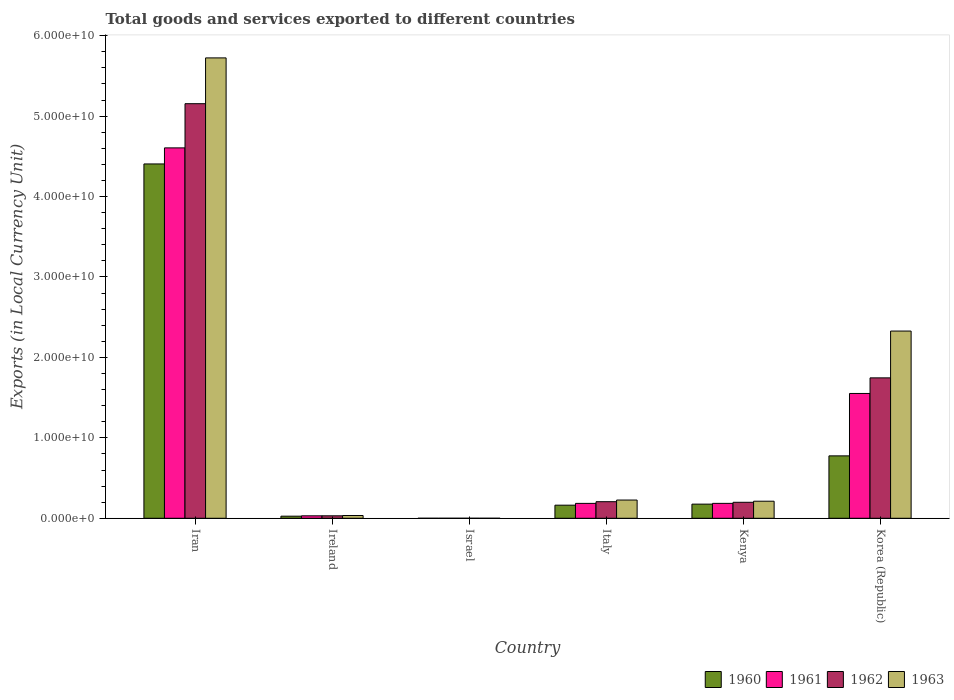How many different coloured bars are there?
Give a very brief answer. 4. Are the number of bars per tick equal to the number of legend labels?
Give a very brief answer. Yes. Are the number of bars on each tick of the X-axis equal?
Make the answer very short. Yes. How many bars are there on the 1st tick from the left?
Give a very brief answer. 4. How many bars are there on the 2nd tick from the right?
Give a very brief answer. 4. What is the label of the 4th group of bars from the left?
Ensure brevity in your answer.  Italy. What is the Amount of goods and services exports in 1961 in Iran?
Ensure brevity in your answer.  4.60e+1. Across all countries, what is the maximum Amount of goods and services exports in 1961?
Your answer should be compact. 4.60e+1. Across all countries, what is the minimum Amount of goods and services exports in 1961?
Your response must be concise. 7.24e+04. In which country was the Amount of goods and services exports in 1962 maximum?
Offer a terse response. Iran. What is the total Amount of goods and services exports in 1960 in the graph?
Ensure brevity in your answer.  5.55e+1. What is the difference between the Amount of goods and services exports in 1962 in Ireland and that in Kenya?
Ensure brevity in your answer.  -1.68e+09. What is the difference between the Amount of goods and services exports in 1960 in Iran and the Amount of goods and services exports in 1962 in Italy?
Keep it short and to the point. 4.20e+1. What is the average Amount of goods and services exports in 1960 per country?
Offer a very short reply. 9.24e+09. What is the difference between the Amount of goods and services exports of/in 1960 and Amount of goods and services exports of/in 1963 in Israel?
Your answer should be very brief. -1.06e+05. In how many countries, is the Amount of goods and services exports in 1960 greater than 38000000000 LCU?
Give a very brief answer. 1. What is the ratio of the Amount of goods and services exports in 1963 in Ireland to that in Kenya?
Your response must be concise. 0.16. What is the difference between the highest and the second highest Amount of goods and services exports in 1962?
Provide a short and direct response. 3.41e+1. What is the difference between the highest and the lowest Amount of goods and services exports in 1962?
Provide a short and direct response. 5.15e+1. In how many countries, is the Amount of goods and services exports in 1961 greater than the average Amount of goods and services exports in 1961 taken over all countries?
Provide a succinct answer. 2. Is the sum of the Amount of goods and services exports in 1961 in Iran and Ireland greater than the maximum Amount of goods and services exports in 1963 across all countries?
Offer a terse response. No. What does the 3rd bar from the right in Italy represents?
Provide a short and direct response. 1961. How many bars are there?
Your answer should be very brief. 24. Are all the bars in the graph horizontal?
Your response must be concise. No. How many countries are there in the graph?
Provide a short and direct response. 6. What is the difference between two consecutive major ticks on the Y-axis?
Offer a very short reply. 1.00e+1. How are the legend labels stacked?
Make the answer very short. Horizontal. What is the title of the graph?
Keep it short and to the point. Total goods and services exported to different countries. Does "1981" appear as one of the legend labels in the graph?
Offer a terse response. No. What is the label or title of the X-axis?
Provide a succinct answer. Country. What is the label or title of the Y-axis?
Your response must be concise. Exports (in Local Currency Unit). What is the Exports (in Local Currency Unit) in 1960 in Iran?
Your answer should be very brief. 4.41e+1. What is the Exports (in Local Currency Unit) in 1961 in Iran?
Make the answer very short. 4.60e+1. What is the Exports (in Local Currency Unit) of 1962 in Iran?
Offer a terse response. 5.15e+1. What is the Exports (in Local Currency Unit) of 1963 in Iran?
Provide a succinct answer. 5.72e+1. What is the Exports (in Local Currency Unit) of 1960 in Ireland?
Offer a very short reply. 2.60e+08. What is the Exports (in Local Currency Unit) of 1961 in Ireland?
Keep it short and to the point. 3.04e+08. What is the Exports (in Local Currency Unit) in 1962 in Ireland?
Offer a very short reply. 3.07e+08. What is the Exports (in Local Currency Unit) of 1963 in Ireland?
Offer a very short reply. 3.43e+08. What is the Exports (in Local Currency Unit) in 1960 in Israel?
Your answer should be very brief. 6.19e+04. What is the Exports (in Local Currency Unit) in 1961 in Israel?
Provide a short and direct response. 7.24e+04. What is the Exports (in Local Currency Unit) in 1962 in Israel?
Give a very brief answer. 1.34e+05. What is the Exports (in Local Currency Unit) in 1963 in Israel?
Ensure brevity in your answer.  1.67e+05. What is the Exports (in Local Currency Unit) of 1960 in Italy?
Keep it short and to the point. 1.63e+09. What is the Exports (in Local Currency Unit) in 1961 in Italy?
Provide a short and direct response. 1.85e+09. What is the Exports (in Local Currency Unit) in 1962 in Italy?
Your answer should be very brief. 2.06e+09. What is the Exports (in Local Currency Unit) in 1963 in Italy?
Ensure brevity in your answer.  2.27e+09. What is the Exports (in Local Currency Unit) in 1960 in Kenya?
Your response must be concise. 1.76e+09. What is the Exports (in Local Currency Unit) in 1961 in Kenya?
Keep it short and to the point. 1.85e+09. What is the Exports (in Local Currency Unit) in 1962 in Kenya?
Offer a terse response. 1.99e+09. What is the Exports (in Local Currency Unit) of 1963 in Kenya?
Give a very brief answer. 2.12e+09. What is the Exports (in Local Currency Unit) of 1960 in Korea (Republic)?
Provide a succinct answer. 7.76e+09. What is the Exports (in Local Currency Unit) of 1961 in Korea (Republic)?
Ensure brevity in your answer.  1.55e+1. What is the Exports (in Local Currency Unit) in 1962 in Korea (Republic)?
Make the answer very short. 1.75e+1. What is the Exports (in Local Currency Unit) of 1963 in Korea (Republic)?
Your response must be concise. 2.33e+1. Across all countries, what is the maximum Exports (in Local Currency Unit) in 1960?
Give a very brief answer. 4.41e+1. Across all countries, what is the maximum Exports (in Local Currency Unit) in 1961?
Your answer should be very brief. 4.60e+1. Across all countries, what is the maximum Exports (in Local Currency Unit) of 1962?
Keep it short and to the point. 5.15e+1. Across all countries, what is the maximum Exports (in Local Currency Unit) of 1963?
Offer a terse response. 5.72e+1. Across all countries, what is the minimum Exports (in Local Currency Unit) in 1960?
Keep it short and to the point. 6.19e+04. Across all countries, what is the minimum Exports (in Local Currency Unit) in 1961?
Ensure brevity in your answer.  7.24e+04. Across all countries, what is the minimum Exports (in Local Currency Unit) of 1962?
Your response must be concise. 1.34e+05. Across all countries, what is the minimum Exports (in Local Currency Unit) in 1963?
Ensure brevity in your answer.  1.67e+05. What is the total Exports (in Local Currency Unit) of 1960 in the graph?
Ensure brevity in your answer.  5.55e+1. What is the total Exports (in Local Currency Unit) in 1961 in the graph?
Ensure brevity in your answer.  6.56e+1. What is the total Exports (in Local Currency Unit) in 1962 in the graph?
Your answer should be compact. 7.34e+1. What is the total Exports (in Local Currency Unit) in 1963 in the graph?
Your answer should be compact. 8.52e+1. What is the difference between the Exports (in Local Currency Unit) in 1960 in Iran and that in Ireland?
Keep it short and to the point. 4.38e+1. What is the difference between the Exports (in Local Currency Unit) in 1961 in Iran and that in Ireland?
Your answer should be very brief. 4.57e+1. What is the difference between the Exports (in Local Currency Unit) in 1962 in Iran and that in Ireland?
Ensure brevity in your answer.  5.12e+1. What is the difference between the Exports (in Local Currency Unit) in 1963 in Iran and that in Ireland?
Your answer should be very brief. 5.69e+1. What is the difference between the Exports (in Local Currency Unit) of 1960 in Iran and that in Israel?
Offer a terse response. 4.41e+1. What is the difference between the Exports (in Local Currency Unit) of 1961 in Iran and that in Israel?
Provide a short and direct response. 4.60e+1. What is the difference between the Exports (in Local Currency Unit) in 1962 in Iran and that in Israel?
Provide a succinct answer. 5.15e+1. What is the difference between the Exports (in Local Currency Unit) in 1963 in Iran and that in Israel?
Keep it short and to the point. 5.72e+1. What is the difference between the Exports (in Local Currency Unit) of 1960 in Iran and that in Italy?
Your answer should be very brief. 4.24e+1. What is the difference between the Exports (in Local Currency Unit) of 1961 in Iran and that in Italy?
Offer a terse response. 4.42e+1. What is the difference between the Exports (in Local Currency Unit) in 1962 in Iran and that in Italy?
Provide a succinct answer. 4.95e+1. What is the difference between the Exports (in Local Currency Unit) of 1963 in Iran and that in Italy?
Your answer should be compact. 5.50e+1. What is the difference between the Exports (in Local Currency Unit) of 1960 in Iran and that in Kenya?
Make the answer very short. 4.23e+1. What is the difference between the Exports (in Local Currency Unit) of 1961 in Iran and that in Kenya?
Provide a short and direct response. 4.42e+1. What is the difference between the Exports (in Local Currency Unit) of 1962 in Iran and that in Kenya?
Offer a terse response. 4.96e+1. What is the difference between the Exports (in Local Currency Unit) in 1963 in Iran and that in Kenya?
Offer a very short reply. 5.51e+1. What is the difference between the Exports (in Local Currency Unit) in 1960 in Iran and that in Korea (Republic)?
Ensure brevity in your answer.  3.63e+1. What is the difference between the Exports (in Local Currency Unit) in 1961 in Iran and that in Korea (Republic)?
Offer a terse response. 3.05e+1. What is the difference between the Exports (in Local Currency Unit) of 1962 in Iran and that in Korea (Republic)?
Your answer should be compact. 3.41e+1. What is the difference between the Exports (in Local Currency Unit) of 1963 in Iran and that in Korea (Republic)?
Offer a terse response. 3.40e+1. What is the difference between the Exports (in Local Currency Unit) in 1960 in Ireland and that in Israel?
Ensure brevity in your answer.  2.60e+08. What is the difference between the Exports (in Local Currency Unit) of 1961 in Ireland and that in Israel?
Your answer should be compact. 3.04e+08. What is the difference between the Exports (in Local Currency Unit) of 1962 in Ireland and that in Israel?
Your answer should be very brief. 3.06e+08. What is the difference between the Exports (in Local Currency Unit) of 1963 in Ireland and that in Israel?
Keep it short and to the point. 3.43e+08. What is the difference between the Exports (in Local Currency Unit) of 1960 in Ireland and that in Italy?
Offer a terse response. -1.37e+09. What is the difference between the Exports (in Local Currency Unit) of 1961 in Ireland and that in Italy?
Provide a succinct answer. -1.55e+09. What is the difference between the Exports (in Local Currency Unit) in 1962 in Ireland and that in Italy?
Make the answer very short. -1.75e+09. What is the difference between the Exports (in Local Currency Unit) in 1963 in Ireland and that in Italy?
Ensure brevity in your answer.  -1.92e+09. What is the difference between the Exports (in Local Currency Unit) of 1960 in Ireland and that in Kenya?
Keep it short and to the point. -1.50e+09. What is the difference between the Exports (in Local Currency Unit) in 1961 in Ireland and that in Kenya?
Make the answer very short. -1.55e+09. What is the difference between the Exports (in Local Currency Unit) in 1962 in Ireland and that in Kenya?
Keep it short and to the point. -1.68e+09. What is the difference between the Exports (in Local Currency Unit) in 1963 in Ireland and that in Kenya?
Make the answer very short. -1.78e+09. What is the difference between the Exports (in Local Currency Unit) in 1960 in Ireland and that in Korea (Republic)?
Your answer should be compact. -7.50e+09. What is the difference between the Exports (in Local Currency Unit) of 1961 in Ireland and that in Korea (Republic)?
Your answer should be compact. -1.52e+1. What is the difference between the Exports (in Local Currency Unit) in 1962 in Ireland and that in Korea (Republic)?
Your answer should be very brief. -1.72e+1. What is the difference between the Exports (in Local Currency Unit) of 1963 in Ireland and that in Korea (Republic)?
Your answer should be very brief. -2.29e+1. What is the difference between the Exports (in Local Currency Unit) of 1960 in Israel and that in Italy?
Offer a terse response. -1.63e+09. What is the difference between the Exports (in Local Currency Unit) in 1961 in Israel and that in Italy?
Keep it short and to the point. -1.85e+09. What is the difference between the Exports (in Local Currency Unit) in 1962 in Israel and that in Italy?
Keep it short and to the point. -2.06e+09. What is the difference between the Exports (in Local Currency Unit) of 1963 in Israel and that in Italy?
Your answer should be compact. -2.27e+09. What is the difference between the Exports (in Local Currency Unit) in 1960 in Israel and that in Kenya?
Your answer should be compact. -1.76e+09. What is the difference between the Exports (in Local Currency Unit) in 1961 in Israel and that in Kenya?
Offer a very short reply. -1.85e+09. What is the difference between the Exports (in Local Currency Unit) of 1962 in Israel and that in Kenya?
Provide a short and direct response. -1.99e+09. What is the difference between the Exports (in Local Currency Unit) of 1963 in Israel and that in Kenya?
Your response must be concise. -2.12e+09. What is the difference between the Exports (in Local Currency Unit) in 1960 in Israel and that in Korea (Republic)?
Offer a terse response. -7.76e+09. What is the difference between the Exports (in Local Currency Unit) in 1961 in Israel and that in Korea (Republic)?
Provide a short and direct response. -1.55e+1. What is the difference between the Exports (in Local Currency Unit) of 1962 in Israel and that in Korea (Republic)?
Provide a succinct answer. -1.75e+1. What is the difference between the Exports (in Local Currency Unit) of 1963 in Israel and that in Korea (Republic)?
Your answer should be very brief. -2.33e+1. What is the difference between the Exports (in Local Currency Unit) in 1960 in Italy and that in Kenya?
Your response must be concise. -1.31e+08. What is the difference between the Exports (in Local Currency Unit) in 1961 in Italy and that in Kenya?
Offer a terse response. -1.45e+06. What is the difference between the Exports (in Local Currency Unit) of 1962 in Italy and that in Kenya?
Offer a terse response. 7.40e+07. What is the difference between the Exports (in Local Currency Unit) of 1963 in Italy and that in Kenya?
Offer a terse response. 1.46e+08. What is the difference between the Exports (in Local Currency Unit) in 1960 in Italy and that in Korea (Republic)?
Your answer should be compact. -6.13e+09. What is the difference between the Exports (in Local Currency Unit) of 1961 in Italy and that in Korea (Republic)?
Ensure brevity in your answer.  -1.37e+1. What is the difference between the Exports (in Local Currency Unit) of 1962 in Italy and that in Korea (Republic)?
Provide a succinct answer. -1.54e+1. What is the difference between the Exports (in Local Currency Unit) of 1963 in Italy and that in Korea (Republic)?
Provide a succinct answer. -2.10e+1. What is the difference between the Exports (in Local Currency Unit) of 1960 in Kenya and that in Korea (Republic)?
Provide a succinct answer. -6.00e+09. What is the difference between the Exports (in Local Currency Unit) of 1961 in Kenya and that in Korea (Republic)?
Your response must be concise. -1.37e+1. What is the difference between the Exports (in Local Currency Unit) in 1962 in Kenya and that in Korea (Republic)?
Offer a terse response. -1.55e+1. What is the difference between the Exports (in Local Currency Unit) in 1963 in Kenya and that in Korea (Republic)?
Give a very brief answer. -2.12e+1. What is the difference between the Exports (in Local Currency Unit) in 1960 in Iran and the Exports (in Local Currency Unit) in 1961 in Ireland?
Provide a succinct answer. 4.37e+1. What is the difference between the Exports (in Local Currency Unit) in 1960 in Iran and the Exports (in Local Currency Unit) in 1962 in Ireland?
Your response must be concise. 4.37e+1. What is the difference between the Exports (in Local Currency Unit) of 1960 in Iran and the Exports (in Local Currency Unit) of 1963 in Ireland?
Give a very brief answer. 4.37e+1. What is the difference between the Exports (in Local Currency Unit) of 1961 in Iran and the Exports (in Local Currency Unit) of 1962 in Ireland?
Make the answer very short. 4.57e+1. What is the difference between the Exports (in Local Currency Unit) in 1961 in Iran and the Exports (in Local Currency Unit) in 1963 in Ireland?
Offer a very short reply. 4.57e+1. What is the difference between the Exports (in Local Currency Unit) of 1962 in Iran and the Exports (in Local Currency Unit) of 1963 in Ireland?
Ensure brevity in your answer.  5.12e+1. What is the difference between the Exports (in Local Currency Unit) in 1960 in Iran and the Exports (in Local Currency Unit) in 1961 in Israel?
Your response must be concise. 4.41e+1. What is the difference between the Exports (in Local Currency Unit) of 1960 in Iran and the Exports (in Local Currency Unit) of 1962 in Israel?
Offer a very short reply. 4.41e+1. What is the difference between the Exports (in Local Currency Unit) of 1960 in Iran and the Exports (in Local Currency Unit) of 1963 in Israel?
Make the answer very short. 4.41e+1. What is the difference between the Exports (in Local Currency Unit) of 1961 in Iran and the Exports (in Local Currency Unit) of 1962 in Israel?
Your response must be concise. 4.60e+1. What is the difference between the Exports (in Local Currency Unit) of 1961 in Iran and the Exports (in Local Currency Unit) of 1963 in Israel?
Offer a terse response. 4.60e+1. What is the difference between the Exports (in Local Currency Unit) of 1962 in Iran and the Exports (in Local Currency Unit) of 1963 in Israel?
Provide a succinct answer. 5.15e+1. What is the difference between the Exports (in Local Currency Unit) in 1960 in Iran and the Exports (in Local Currency Unit) in 1961 in Italy?
Offer a terse response. 4.22e+1. What is the difference between the Exports (in Local Currency Unit) of 1960 in Iran and the Exports (in Local Currency Unit) of 1962 in Italy?
Provide a succinct answer. 4.20e+1. What is the difference between the Exports (in Local Currency Unit) of 1960 in Iran and the Exports (in Local Currency Unit) of 1963 in Italy?
Provide a succinct answer. 4.18e+1. What is the difference between the Exports (in Local Currency Unit) of 1961 in Iran and the Exports (in Local Currency Unit) of 1962 in Italy?
Provide a short and direct response. 4.40e+1. What is the difference between the Exports (in Local Currency Unit) in 1961 in Iran and the Exports (in Local Currency Unit) in 1963 in Italy?
Offer a very short reply. 4.38e+1. What is the difference between the Exports (in Local Currency Unit) in 1962 in Iran and the Exports (in Local Currency Unit) in 1963 in Italy?
Your answer should be very brief. 4.93e+1. What is the difference between the Exports (in Local Currency Unit) in 1960 in Iran and the Exports (in Local Currency Unit) in 1961 in Kenya?
Make the answer very short. 4.22e+1. What is the difference between the Exports (in Local Currency Unit) of 1960 in Iran and the Exports (in Local Currency Unit) of 1962 in Kenya?
Your answer should be very brief. 4.21e+1. What is the difference between the Exports (in Local Currency Unit) in 1960 in Iran and the Exports (in Local Currency Unit) in 1963 in Kenya?
Your response must be concise. 4.19e+1. What is the difference between the Exports (in Local Currency Unit) in 1961 in Iran and the Exports (in Local Currency Unit) in 1962 in Kenya?
Ensure brevity in your answer.  4.41e+1. What is the difference between the Exports (in Local Currency Unit) of 1961 in Iran and the Exports (in Local Currency Unit) of 1963 in Kenya?
Offer a terse response. 4.39e+1. What is the difference between the Exports (in Local Currency Unit) in 1962 in Iran and the Exports (in Local Currency Unit) in 1963 in Kenya?
Ensure brevity in your answer.  4.94e+1. What is the difference between the Exports (in Local Currency Unit) in 1960 in Iran and the Exports (in Local Currency Unit) in 1961 in Korea (Republic)?
Ensure brevity in your answer.  2.85e+1. What is the difference between the Exports (in Local Currency Unit) in 1960 in Iran and the Exports (in Local Currency Unit) in 1962 in Korea (Republic)?
Your response must be concise. 2.66e+1. What is the difference between the Exports (in Local Currency Unit) of 1960 in Iran and the Exports (in Local Currency Unit) of 1963 in Korea (Republic)?
Your response must be concise. 2.08e+1. What is the difference between the Exports (in Local Currency Unit) of 1961 in Iran and the Exports (in Local Currency Unit) of 1962 in Korea (Republic)?
Provide a succinct answer. 2.86e+1. What is the difference between the Exports (in Local Currency Unit) in 1961 in Iran and the Exports (in Local Currency Unit) in 1963 in Korea (Republic)?
Your answer should be compact. 2.28e+1. What is the difference between the Exports (in Local Currency Unit) of 1962 in Iran and the Exports (in Local Currency Unit) of 1963 in Korea (Republic)?
Make the answer very short. 2.83e+1. What is the difference between the Exports (in Local Currency Unit) of 1960 in Ireland and the Exports (in Local Currency Unit) of 1961 in Israel?
Provide a short and direct response. 2.60e+08. What is the difference between the Exports (in Local Currency Unit) in 1960 in Ireland and the Exports (in Local Currency Unit) in 1962 in Israel?
Your response must be concise. 2.60e+08. What is the difference between the Exports (in Local Currency Unit) of 1960 in Ireland and the Exports (in Local Currency Unit) of 1963 in Israel?
Your response must be concise. 2.60e+08. What is the difference between the Exports (in Local Currency Unit) in 1961 in Ireland and the Exports (in Local Currency Unit) in 1962 in Israel?
Your answer should be compact. 3.04e+08. What is the difference between the Exports (in Local Currency Unit) in 1961 in Ireland and the Exports (in Local Currency Unit) in 1963 in Israel?
Make the answer very short. 3.04e+08. What is the difference between the Exports (in Local Currency Unit) in 1962 in Ireland and the Exports (in Local Currency Unit) in 1963 in Israel?
Keep it short and to the point. 3.06e+08. What is the difference between the Exports (in Local Currency Unit) of 1960 in Ireland and the Exports (in Local Currency Unit) of 1961 in Italy?
Provide a succinct answer. -1.59e+09. What is the difference between the Exports (in Local Currency Unit) of 1960 in Ireland and the Exports (in Local Currency Unit) of 1962 in Italy?
Offer a very short reply. -1.80e+09. What is the difference between the Exports (in Local Currency Unit) of 1960 in Ireland and the Exports (in Local Currency Unit) of 1963 in Italy?
Ensure brevity in your answer.  -2.01e+09. What is the difference between the Exports (in Local Currency Unit) in 1961 in Ireland and the Exports (in Local Currency Unit) in 1962 in Italy?
Keep it short and to the point. -1.76e+09. What is the difference between the Exports (in Local Currency Unit) of 1961 in Ireland and the Exports (in Local Currency Unit) of 1963 in Italy?
Give a very brief answer. -1.96e+09. What is the difference between the Exports (in Local Currency Unit) of 1962 in Ireland and the Exports (in Local Currency Unit) of 1963 in Italy?
Make the answer very short. -1.96e+09. What is the difference between the Exports (in Local Currency Unit) of 1960 in Ireland and the Exports (in Local Currency Unit) of 1961 in Kenya?
Provide a short and direct response. -1.59e+09. What is the difference between the Exports (in Local Currency Unit) in 1960 in Ireland and the Exports (in Local Currency Unit) in 1962 in Kenya?
Ensure brevity in your answer.  -1.73e+09. What is the difference between the Exports (in Local Currency Unit) of 1960 in Ireland and the Exports (in Local Currency Unit) of 1963 in Kenya?
Make the answer very short. -1.86e+09. What is the difference between the Exports (in Local Currency Unit) of 1961 in Ireland and the Exports (in Local Currency Unit) of 1962 in Kenya?
Your answer should be compact. -1.68e+09. What is the difference between the Exports (in Local Currency Unit) in 1961 in Ireland and the Exports (in Local Currency Unit) in 1963 in Kenya?
Keep it short and to the point. -1.82e+09. What is the difference between the Exports (in Local Currency Unit) of 1962 in Ireland and the Exports (in Local Currency Unit) of 1963 in Kenya?
Make the answer very short. -1.81e+09. What is the difference between the Exports (in Local Currency Unit) of 1960 in Ireland and the Exports (in Local Currency Unit) of 1961 in Korea (Republic)?
Your answer should be very brief. -1.53e+1. What is the difference between the Exports (in Local Currency Unit) in 1960 in Ireland and the Exports (in Local Currency Unit) in 1962 in Korea (Republic)?
Your answer should be very brief. -1.72e+1. What is the difference between the Exports (in Local Currency Unit) in 1960 in Ireland and the Exports (in Local Currency Unit) in 1963 in Korea (Republic)?
Offer a very short reply. -2.30e+1. What is the difference between the Exports (in Local Currency Unit) in 1961 in Ireland and the Exports (in Local Currency Unit) in 1962 in Korea (Republic)?
Offer a terse response. -1.72e+1. What is the difference between the Exports (in Local Currency Unit) in 1961 in Ireland and the Exports (in Local Currency Unit) in 1963 in Korea (Republic)?
Offer a very short reply. -2.30e+1. What is the difference between the Exports (in Local Currency Unit) of 1962 in Ireland and the Exports (in Local Currency Unit) of 1963 in Korea (Republic)?
Give a very brief answer. -2.30e+1. What is the difference between the Exports (in Local Currency Unit) of 1960 in Israel and the Exports (in Local Currency Unit) of 1961 in Italy?
Give a very brief answer. -1.85e+09. What is the difference between the Exports (in Local Currency Unit) in 1960 in Israel and the Exports (in Local Currency Unit) in 1962 in Italy?
Provide a short and direct response. -2.06e+09. What is the difference between the Exports (in Local Currency Unit) of 1960 in Israel and the Exports (in Local Currency Unit) of 1963 in Italy?
Offer a terse response. -2.27e+09. What is the difference between the Exports (in Local Currency Unit) of 1961 in Israel and the Exports (in Local Currency Unit) of 1962 in Italy?
Give a very brief answer. -2.06e+09. What is the difference between the Exports (in Local Currency Unit) of 1961 in Israel and the Exports (in Local Currency Unit) of 1963 in Italy?
Ensure brevity in your answer.  -2.27e+09. What is the difference between the Exports (in Local Currency Unit) in 1962 in Israel and the Exports (in Local Currency Unit) in 1963 in Italy?
Your response must be concise. -2.27e+09. What is the difference between the Exports (in Local Currency Unit) of 1960 in Israel and the Exports (in Local Currency Unit) of 1961 in Kenya?
Offer a terse response. -1.85e+09. What is the difference between the Exports (in Local Currency Unit) in 1960 in Israel and the Exports (in Local Currency Unit) in 1962 in Kenya?
Provide a short and direct response. -1.99e+09. What is the difference between the Exports (in Local Currency Unit) of 1960 in Israel and the Exports (in Local Currency Unit) of 1963 in Kenya?
Your response must be concise. -2.12e+09. What is the difference between the Exports (in Local Currency Unit) in 1961 in Israel and the Exports (in Local Currency Unit) in 1962 in Kenya?
Give a very brief answer. -1.99e+09. What is the difference between the Exports (in Local Currency Unit) in 1961 in Israel and the Exports (in Local Currency Unit) in 1963 in Kenya?
Your response must be concise. -2.12e+09. What is the difference between the Exports (in Local Currency Unit) in 1962 in Israel and the Exports (in Local Currency Unit) in 1963 in Kenya?
Your answer should be compact. -2.12e+09. What is the difference between the Exports (in Local Currency Unit) of 1960 in Israel and the Exports (in Local Currency Unit) of 1961 in Korea (Republic)?
Give a very brief answer. -1.55e+1. What is the difference between the Exports (in Local Currency Unit) of 1960 in Israel and the Exports (in Local Currency Unit) of 1962 in Korea (Republic)?
Ensure brevity in your answer.  -1.75e+1. What is the difference between the Exports (in Local Currency Unit) in 1960 in Israel and the Exports (in Local Currency Unit) in 1963 in Korea (Republic)?
Provide a short and direct response. -2.33e+1. What is the difference between the Exports (in Local Currency Unit) of 1961 in Israel and the Exports (in Local Currency Unit) of 1962 in Korea (Republic)?
Offer a very short reply. -1.75e+1. What is the difference between the Exports (in Local Currency Unit) of 1961 in Israel and the Exports (in Local Currency Unit) of 1963 in Korea (Republic)?
Provide a succinct answer. -2.33e+1. What is the difference between the Exports (in Local Currency Unit) of 1962 in Israel and the Exports (in Local Currency Unit) of 1963 in Korea (Republic)?
Your response must be concise. -2.33e+1. What is the difference between the Exports (in Local Currency Unit) of 1960 in Italy and the Exports (in Local Currency Unit) of 1961 in Kenya?
Your response must be concise. -2.27e+08. What is the difference between the Exports (in Local Currency Unit) in 1960 in Italy and the Exports (in Local Currency Unit) in 1962 in Kenya?
Provide a succinct answer. -3.60e+08. What is the difference between the Exports (in Local Currency Unit) of 1960 in Italy and the Exports (in Local Currency Unit) of 1963 in Kenya?
Your response must be concise. -4.94e+08. What is the difference between the Exports (in Local Currency Unit) of 1961 in Italy and the Exports (in Local Currency Unit) of 1962 in Kenya?
Keep it short and to the point. -1.35e+08. What is the difference between the Exports (in Local Currency Unit) in 1961 in Italy and the Exports (in Local Currency Unit) in 1963 in Kenya?
Your answer should be very brief. -2.68e+08. What is the difference between the Exports (in Local Currency Unit) in 1962 in Italy and the Exports (in Local Currency Unit) in 1963 in Kenya?
Ensure brevity in your answer.  -5.95e+07. What is the difference between the Exports (in Local Currency Unit) of 1960 in Italy and the Exports (in Local Currency Unit) of 1961 in Korea (Republic)?
Your response must be concise. -1.39e+1. What is the difference between the Exports (in Local Currency Unit) in 1960 in Italy and the Exports (in Local Currency Unit) in 1962 in Korea (Republic)?
Keep it short and to the point. -1.58e+1. What is the difference between the Exports (in Local Currency Unit) of 1960 in Italy and the Exports (in Local Currency Unit) of 1963 in Korea (Republic)?
Your answer should be very brief. -2.16e+1. What is the difference between the Exports (in Local Currency Unit) of 1961 in Italy and the Exports (in Local Currency Unit) of 1962 in Korea (Republic)?
Make the answer very short. -1.56e+1. What is the difference between the Exports (in Local Currency Unit) of 1961 in Italy and the Exports (in Local Currency Unit) of 1963 in Korea (Republic)?
Give a very brief answer. -2.14e+1. What is the difference between the Exports (in Local Currency Unit) of 1962 in Italy and the Exports (in Local Currency Unit) of 1963 in Korea (Republic)?
Offer a very short reply. -2.12e+1. What is the difference between the Exports (in Local Currency Unit) of 1960 in Kenya and the Exports (in Local Currency Unit) of 1961 in Korea (Republic)?
Your response must be concise. -1.38e+1. What is the difference between the Exports (in Local Currency Unit) of 1960 in Kenya and the Exports (in Local Currency Unit) of 1962 in Korea (Republic)?
Provide a succinct answer. -1.57e+1. What is the difference between the Exports (in Local Currency Unit) of 1960 in Kenya and the Exports (in Local Currency Unit) of 1963 in Korea (Republic)?
Give a very brief answer. -2.15e+1. What is the difference between the Exports (in Local Currency Unit) of 1961 in Kenya and the Exports (in Local Currency Unit) of 1962 in Korea (Republic)?
Your answer should be compact. -1.56e+1. What is the difference between the Exports (in Local Currency Unit) of 1961 in Kenya and the Exports (in Local Currency Unit) of 1963 in Korea (Republic)?
Offer a terse response. -2.14e+1. What is the difference between the Exports (in Local Currency Unit) of 1962 in Kenya and the Exports (in Local Currency Unit) of 1963 in Korea (Republic)?
Your answer should be very brief. -2.13e+1. What is the average Exports (in Local Currency Unit) in 1960 per country?
Give a very brief answer. 9.24e+09. What is the average Exports (in Local Currency Unit) in 1961 per country?
Your answer should be compact. 1.09e+1. What is the average Exports (in Local Currency Unit) in 1962 per country?
Your answer should be very brief. 1.22e+1. What is the average Exports (in Local Currency Unit) in 1963 per country?
Ensure brevity in your answer.  1.42e+1. What is the difference between the Exports (in Local Currency Unit) in 1960 and Exports (in Local Currency Unit) in 1961 in Iran?
Your answer should be very brief. -2.00e+09. What is the difference between the Exports (in Local Currency Unit) of 1960 and Exports (in Local Currency Unit) of 1962 in Iran?
Offer a very short reply. -7.49e+09. What is the difference between the Exports (in Local Currency Unit) in 1960 and Exports (in Local Currency Unit) in 1963 in Iran?
Offer a terse response. -1.32e+1. What is the difference between the Exports (in Local Currency Unit) of 1961 and Exports (in Local Currency Unit) of 1962 in Iran?
Make the answer very short. -5.49e+09. What is the difference between the Exports (in Local Currency Unit) of 1961 and Exports (in Local Currency Unit) of 1963 in Iran?
Give a very brief answer. -1.12e+1. What is the difference between the Exports (in Local Currency Unit) in 1962 and Exports (in Local Currency Unit) in 1963 in Iran?
Give a very brief answer. -5.69e+09. What is the difference between the Exports (in Local Currency Unit) in 1960 and Exports (in Local Currency Unit) in 1961 in Ireland?
Provide a succinct answer. -4.43e+07. What is the difference between the Exports (in Local Currency Unit) in 1960 and Exports (in Local Currency Unit) in 1962 in Ireland?
Provide a succinct answer. -4.69e+07. What is the difference between the Exports (in Local Currency Unit) in 1960 and Exports (in Local Currency Unit) in 1963 in Ireland?
Make the answer very short. -8.33e+07. What is the difference between the Exports (in Local Currency Unit) of 1961 and Exports (in Local Currency Unit) of 1962 in Ireland?
Offer a terse response. -2.58e+06. What is the difference between the Exports (in Local Currency Unit) of 1961 and Exports (in Local Currency Unit) of 1963 in Ireland?
Your answer should be compact. -3.90e+07. What is the difference between the Exports (in Local Currency Unit) of 1962 and Exports (in Local Currency Unit) of 1963 in Ireland?
Offer a very short reply. -3.64e+07. What is the difference between the Exports (in Local Currency Unit) in 1960 and Exports (in Local Currency Unit) in 1961 in Israel?
Your answer should be compact. -1.05e+04. What is the difference between the Exports (in Local Currency Unit) of 1960 and Exports (in Local Currency Unit) of 1962 in Israel?
Offer a terse response. -7.21e+04. What is the difference between the Exports (in Local Currency Unit) in 1960 and Exports (in Local Currency Unit) in 1963 in Israel?
Your answer should be compact. -1.06e+05. What is the difference between the Exports (in Local Currency Unit) in 1961 and Exports (in Local Currency Unit) in 1962 in Israel?
Make the answer very short. -6.16e+04. What is the difference between the Exports (in Local Currency Unit) in 1961 and Exports (in Local Currency Unit) in 1963 in Israel?
Your answer should be very brief. -9.50e+04. What is the difference between the Exports (in Local Currency Unit) in 1962 and Exports (in Local Currency Unit) in 1963 in Israel?
Ensure brevity in your answer.  -3.34e+04. What is the difference between the Exports (in Local Currency Unit) of 1960 and Exports (in Local Currency Unit) of 1961 in Italy?
Provide a succinct answer. -2.25e+08. What is the difference between the Exports (in Local Currency Unit) of 1960 and Exports (in Local Currency Unit) of 1962 in Italy?
Your response must be concise. -4.34e+08. What is the difference between the Exports (in Local Currency Unit) of 1960 and Exports (in Local Currency Unit) of 1963 in Italy?
Offer a terse response. -6.40e+08. What is the difference between the Exports (in Local Currency Unit) in 1961 and Exports (in Local Currency Unit) in 1962 in Italy?
Offer a very short reply. -2.09e+08. What is the difference between the Exports (in Local Currency Unit) of 1961 and Exports (in Local Currency Unit) of 1963 in Italy?
Provide a succinct answer. -4.14e+08. What is the difference between the Exports (in Local Currency Unit) of 1962 and Exports (in Local Currency Unit) of 1963 in Italy?
Provide a short and direct response. -2.05e+08. What is the difference between the Exports (in Local Currency Unit) of 1960 and Exports (in Local Currency Unit) of 1961 in Kenya?
Your response must be concise. -9.56e+07. What is the difference between the Exports (in Local Currency Unit) of 1960 and Exports (in Local Currency Unit) of 1962 in Kenya?
Offer a very short reply. -2.29e+08. What is the difference between the Exports (in Local Currency Unit) of 1960 and Exports (in Local Currency Unit) of 1963 in Kenya?
Ensure brevity in your answer.  -3.63e+08. What is the difference between the Exports (in Local Currency Unit) of 1961 and Exports (in Local Currency Unit) of 1962 in Kenya?
Offer a very short reply. -1.33e+08. What is the difference between the Exports (in Local Currency Unit) of 1961 and Exports (in Local Currency Unit) of 1963 in Kenya?
Offer a very short reply. -2.67e+08. What is the difference between the Exports (in Local Currency Unit) in 1962 and Exports (in Local Currency Unit) in 1963 in Kenya?
Ensure brevity in your answer.  -1.34e+08. What is the difference between the Exports (in Local Currency Unit) of 1960 and Exports (in Local Currency Unit) of 1961 in Korea (Republic)?
Ensure brevity in your answer.  -7.76e+09. What is the difference between the Exports (in Local Currency Unit) in 1960 and Exports (in Local Currency Unit) in 1962 in Korea (Republic)?
Provide a succinct answer. -9.70e+09. What is the difference between the Exports (in Local Currency Unit) of 1960 and Exports (in Local Currency Unit) of 1963 in Korea (Republic)?
Ensure brevity in your answer.  -1.55e+1. What is the difference between the Exports (in Local Currency Unit) in 1961 and Exports (in Local Currency Unit) in 1962 in Korea (Republic)?
Ensure brevity in your answer.  -1.94e+09. What is the difference between the Exports (in Local Currency Unit) of 1961 and Exports (in Local Currency Unit) of 1963 in Korea (Republic)?
Your answer should be compact. -7.76e+09. What is the difference between the Exports (in Local Currency Unit) of 1962 and Exports (in Local Currency Unit) of 1963 in Korea (Republic)?
Make the answer very short. -5.82e+09. What is the ratio of the Exports (in Local Currency Unit) of 1960 in Iran to that in Ireland?
Your answer should be very brief. 169.64. What is the ratio of the Exports (in Local Currency Unit) of 1961 in Iran to that in Ireland?
Ensure brevity in your answer.  151.49. What is the ratio of the Exports (in Local Currency Unit) in 1962 in Iran to that in Ireland?
Make the answer very short. 168.13. What is the ratio of the Exports (in Local Currency Unit) of 1963 in Iran to that in Ireland?
Your answer should be compact. 166.87. What is the ratio of the Exports (in Local Currency Unit) in 1960 in Iran to that in Israel?
Your answer should be compact. 7.12e+05. What is the ratio of the Exports (in Local Currency Unit) of 1961 in Iran to that in Israel?
Offer a very short reply. 6.36e+05. What is the ratio of the Exports (in Local Currency Unit) of 1962 in Iran to that in Israel?
Keep it short and to the point. 3.85e+05. What is the ratio of the Exports (in Local Currency Unit) in 1963 in Iran to that in Israel?
Provide a short and direct response. 3.42e+05. What is the ratio of the Exports (in Local Currency Unit) in 1960 in Iran to that in Italy?
Your answer should be compact. 27.08. What is the ratio of the Exports (in Local Currency Unit) of 1961 in Iran to that in Italy?
Keep it short and to the point. 24.87. What is the ratio of the Exports (in Local Currency Unit) in 1962 in Iran to that in Italy?
Your answer should be very brief. 25.01. What is the ratio of the Exports (in Local Currency Unit) in 1963 in Iran to that in Italy?
Offer a terse response. 25.26. What is the ratio of the Exports (in Local Currency Unit) of 1960 in Iran to that in Kenya?
Provide a succinct answer. 25.07. What is the ratio of the Exports (in Local Currency Unit) of 1961 in Iran to that in Kenya?
Offer a terse response. 24.85. What is the ratio of the Exports (in Local Currency Unit) of 1962 in Iran to that in Kenya?
Your answer should be very brief. 25.95. What is the ratio of the Exports (in Local Currency Unit) of 1963 in Iran to that in Kenya?
Your response must be concise. 27. What is the ratio of the Exports (in Local Currency Unit) of 1960 in Iran to that in Korea (Republic)?
Ensure brevity in your answer.  5.68. What is the ratio of the Exports (in Local Currency Unit) in 1961 in Iran to that in Korea (Republic)?
Offer a terse response. 2.97. What is the ratio of the Exports (in Local Currency Unit) in 1962 in Iran to that in Korea (Republic)?
Your response must be concise. 2.95. What is the ratio of the Exports (in Local Currency Unit) of 1963 in Iran to that in Korea (Republic)?
Give a very brief answer. 2.46. What is the ratio of the Exports (in Local Currency Unit) in 1960 in Ireland to that in Israel?
Offer a terse response. 4195.01. What is the ratio of the Exports (in Local Currency Unit) in 1961 in Ireland to that in Israel?
Your answer should be very brief. 4198.66. What is the ratio of the Exports (in Local Currency Unit) in 1962 in Ireland to that in Israel?
Offer a terse response. 2287.81. What is the ratio of the Exports (in Local Currency Unit) in 1963 in Ireland to that in Israel?
Provide a succinct answer. 2048.97. What is the ratio of the Exports (in Local Currency Unit) of 1960 in Ireland to that in Italy?
Provide a short and direct response. 0.16. What is the ratio of the Exports (in Local Currency Unit) in 1961 in Ireland to that in Italy?
Ensure brevity in your answer.  0.16. What is the ratio of the Exports (in Local Currency Unit) in 1962 in Ireland to that in Italy?
Make the answer very short. 0.15. What is the ratio of the Exports (in Local Currency Unit) of 1963 in Ireland to that in Italy?
Provide a short and direct response. 0.15. What is the ratio of the Exports (in Local Currency Unit) of 1960 in Ireland to that in Kenya?
Offer a very short reply. 0.15. What is the ratio of the Exports (in Local Currency Unit) in 1961 in Ireland to that in Kenya?
Your answer should be very brief. 0.16. What is the ratio of the Exports (in Local Currency Unit) of 1962 in Ireland to that in Kenya?
Give a very brief answer. 0.15. What is the ratio of the Exports (in Local Currency Unit) of 1963 in Ireland to that in Kenya?
Your response must be concise. 0.16. What is the ratio of the Exports (in Local Currency Unit) of 1960 in Ireland to that in Korea (Republic)?
Your answer should be very brief. 0.03. What is the ratio of the Exports (in Local Currency Unit) in 1961 in Ireland to that in Korea (Republic)?
Your answer should be compact. 0.02. What is the ratio of the Exports (in Local Currency Unit) in 1962 in Ireland to that in Korea (Republic)?
Keep it short and to the point. 0.02. What is the ratio of the Exports (in Local Currency Unit) in 1963 in Ireland to that in Korea (Republic)?
Make the answer very short. 0.01. What is the ratio of the Exports (in Local Currency Unit) in 1961 in Israel to that in Italy?
Keep it short and to the point. 0. What is the ratio of the Exports (in Local Currency Unit) in 1960 in Israel to that in Kenya?
Provide a succinct answer. 0. What is the ratio of the Exports (in Local Currency Unit) of 1960 in Israel to that in Korea (Republic)?
Your answer should be compact. 0. What is the ratio of the Exports (in Local Currency Unit) of 1962 in Israel to that in Korea (Republic)?
Your answer should be very brief. 0. What is the ratio of the Exports (in Local Currency Unit) in 1960 in Italy to that in Kenya?
Offer a terse response. 0.93. What is the ratio of the Exports (in Local Currency Unit) of 1962 in Italy to that in Kenya?
Provide a succinct answer. 1.04. What is the ratio of the Exports (in Local Currency Unit) of 1963 in Italy to that in Kenya?
Ensure brevity in your answer.  1.07. What is the ratio of the Exports (in Local Currency Unit) in 1960 in Italy to that in Korea (Republic)?
Offer a very short reply. 0.21. What is the ratio of the Exports (in Local Currency Unit) in 1961 in Italy to that in Korea (Republic)?
Keep it short and to the point. 0.12. What is the ratio of the Exports (in Local Currency Unit) of 1962 in Italy to that in Korea (Republic)?
Offer a terse response. 0.12. What is the ratio of the Exports (in Local Currency Unit) in 1963 in Italy to that in Korea (Republic)?
Provide a short and direct response. 0.1. What is the ratio of the Exports (in Local Currency Unit) of 1960 in Kenya to that in Korea (Republic)?
Make the answer very short. 0.23. What is the ratio of the Exports (in Local Currency Unit) in 1961 in Kenya to that in Korea (Republic)?
Provide a short and direct response. 0.12. What is the ratio of the Exports (in Local Currency Unit) of 1962 in Kenya to that in Korea (Republic)?
Keep it short and to the point. 0.11. What is the ratio of the Exports (in Local Currency Unit) of 1963 in Kenya to that in Korea (Republic)?
Offer a very short reply. 0.09. What is the difference between the highest and the second highest Exports (in Local Currency Unit) of 1960?
Your answer should be very brief. 3.63e+1. What is the difference between the highest and the second highest Exports (in Local Currency Unit) of 1961?
Provide a short and direct response. 3.05e+1. What is the difference between the highest and the second highest Exports (in Local Currency Unit) of 1962?
Make the answer very short. 3.41e+1. What is the difference between the highest and the second highest Exports (in Local Currency Unit) of 1963?
Offer a terse response. 3.40e+1. What is the difference between the highest and the lowest Exports (in Local Currency Unit) of 1960?
Make the answer very short. 4.41e+1. What is the difference between the highest and the lowest Exports (in Local Currency Unit) in 1961?
Provide a succinct answer. 4.60e+1. What is the difference between the highest and the lowest Exports (in Local Currency Unit) in 1962?
Your response must be concise. 5.15e+1. What is the difference between the highest and the lowest Exports (in Local Currency Unit) of 1963?
Ensure brevity in your answer.  5.72e+1. 